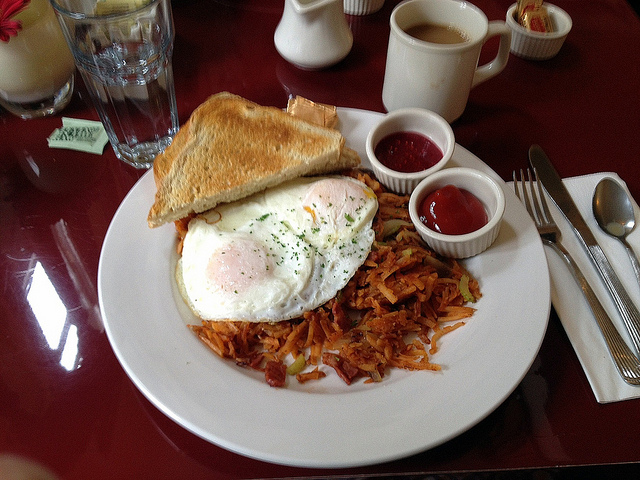What kind of occasion or setting does this breakfast scene suggest? This breakfast setup, with its hearty portions and traditional American foods served on a simple white plate, suggests a casual dining environment, possibly in a diner or a homestyle restaurant. The inclusion of basic tableware and condiments hints at a focus on comfort and simplicity, ideal for a relaxed morning meal. 